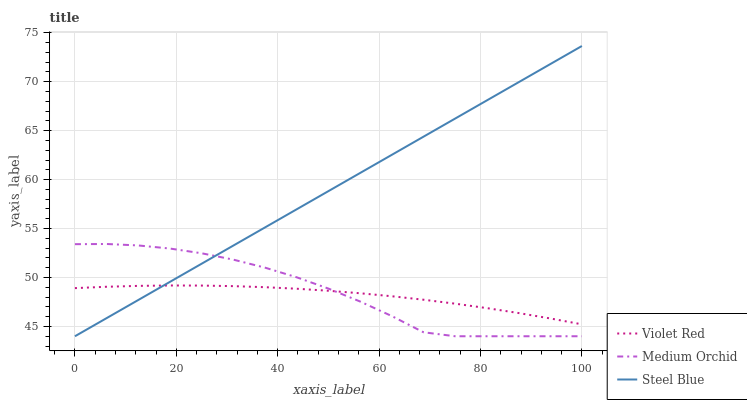Does Violet Red have the minimum area under the curve?
Answer yes or no. Yes. Does Steel Blue have the maximum area under the curve?
Answer yes or no. Yes. Does Medium Orchid have the minimum area under the curve?
Answer yes or no. No. Does Medium Orchid have the maximum area under the curve?
Answer yes or no. No. Is Steel Blue the smoothest?
Answer yes or no. Yes. Is Medium Orchid the roughest?
Answer yes or no. Yes. Is Medium Orchid the smoothest?
Answer yes or no. No. Is Steel Blue the roughest?
Answer yes or no. No. Does Medium Orchid have the lowest value?
Answer yes or no. Yes. Does Steel Blue have the highest value?
Answer yes or no. Yes. Does Medium Orchid have the highest value?
Answer yes or no. No. Does Violet Red intersect Medium Orchid?
Answer yes or no. Yes. Is Violet Red less than Medium Orchid?
Answer yes or no. No. Is Violet Red greater than Medium Orchid?
Answer yes or no. No. 